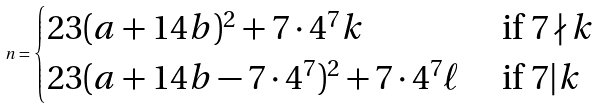Convert formula to latex. <formula><loc_0><loc_0><loc_500><loc_500>n = \begin{cases} 2 3 ( a + 1 4 b ) ^ { 2 } + 7 \cdot 4 ^ { 7 } k & \text { if } 7 \nmid k \\ 2 3 ( a + 1 4 b - 7 \cdot 4 ^ { 7 } ) ^ { 2 } + 7 \cdot 4 ^ { 7 } \ell & \text { if } 7 | k \end{cases}</formula> 